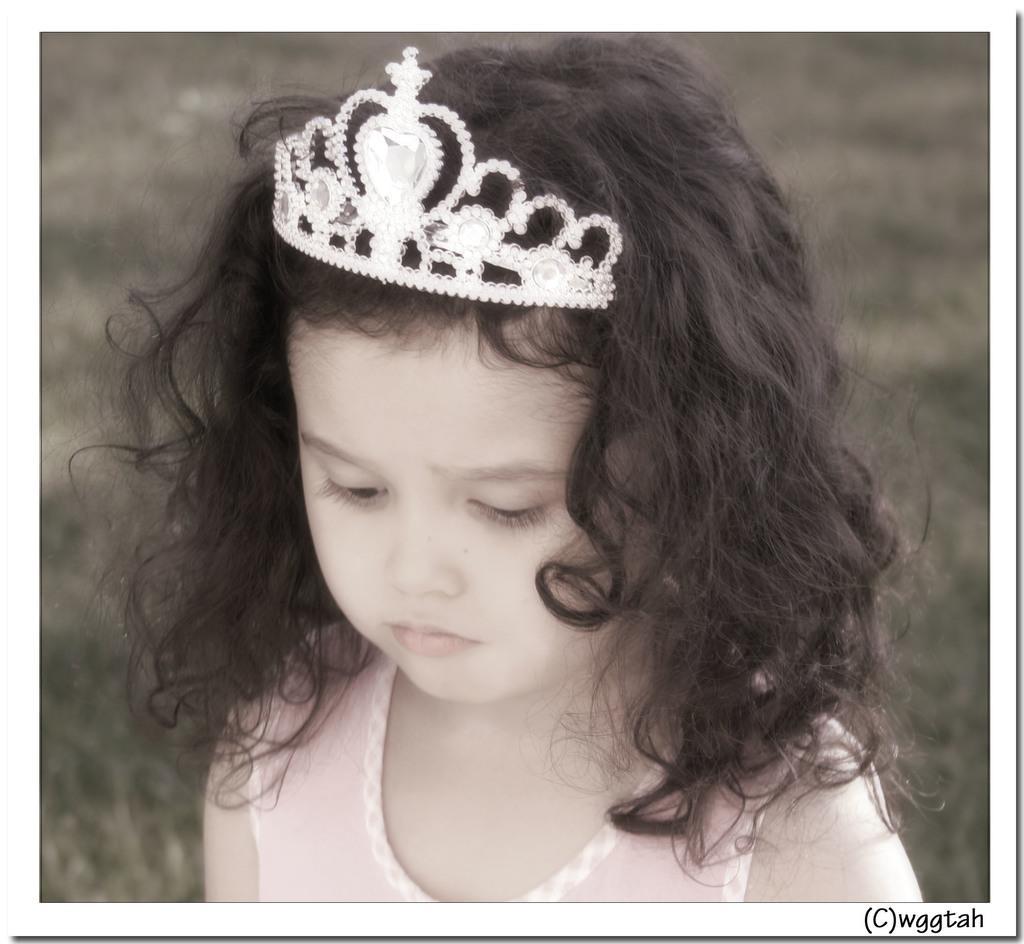Can you describe this image briefly? In this picture there is a girl in the center wearing a Crown on her head and the background is blurry. 